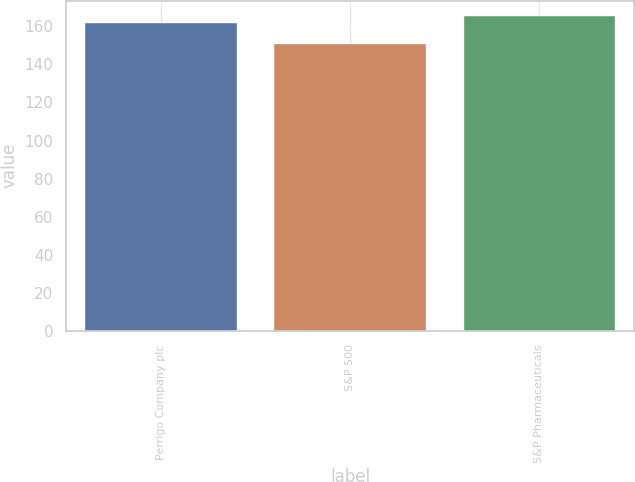Convert chart to OTSL. <chart><loc_0><loc_0><loc_500><loc_500><bar_chart><fcel>Perrigo Company plc<fcel>S&P 500<fcel>S&P Pharmaceuticals<nl><fcel>161.6<fcel>150.51<fcel>165.27<nl></chart> 